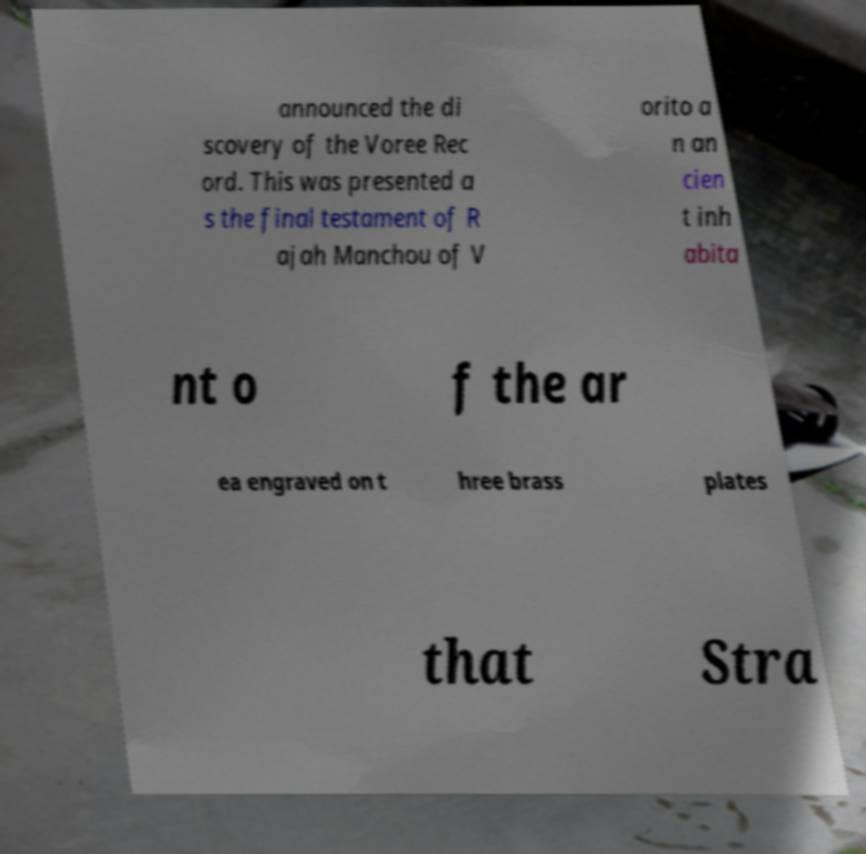What messages or text are displayed in this image? I need them in a readable, typed format. announced the di scovery of the Voree Rec ord. This was presented a s the final testament of R ajah Manchou of V orito a n an cien t inh abita nt o f the ar ea engraved on t hree brass plates that Stra 